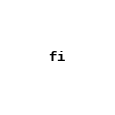Convert code to text. <code><loc_0><loc_0><loc_500><loc_500><_Bash_>fi

</code> 